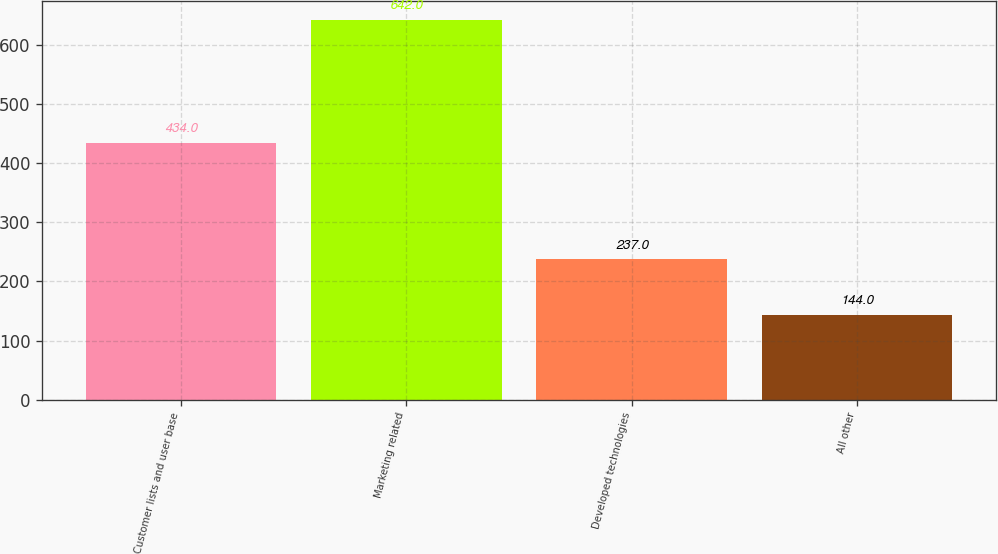Convert chart. <chart><loc_0><loc_0><loc_500><loc_500><bar_chart><fcel>Customer lists and user base<fcel>Marketing related<fcel>Developed technologies<fcel>All other<nl><fcel>434<fcel>642<fcel>237<fcel>144<nl></chart> 